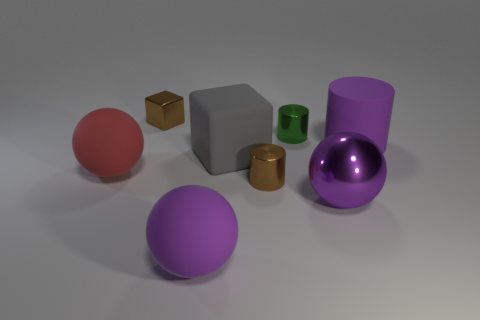What size is the brown metal cube?
Your response must be concise. Small. The metal cylinder right of the brown shiny object that is in front of the metal cylinder that is behind the big purple cylinder is what color?
Make the answer very short. Green. Does the cylinder that is right of the purple shiny object have the same color as the metal block?
Make the answer very short. No. How many small metallic things are both in front of the small brown cube and behind the brown metallic cylinder?
Your response must be concise. 1. There is another rubber thing that is the same shape as the small green object; what is its size?
Give a very brief answer. Large. There is a large purple matte object that is right of the big purple rubber thing that is in front of the purple rubber cylinder; what number of large gray things are on the left side of it?
Ensure brevity in your answer.  1. The big matte cylinder that is to the right of the big thing that is on the left side of the purple rubber sphere is what color?
Provide a short and direct response. Purple. What number of other objects are there of the same material as the small cube?
Offer a terse response. 3. There is a small shiny cylinder that is behind the large purple cylinder; what number of small cylinders are behind it?
Make the answer very short. 0. Are there any other things that have the same shape as the red object?
Make the answer very short. Yes. 